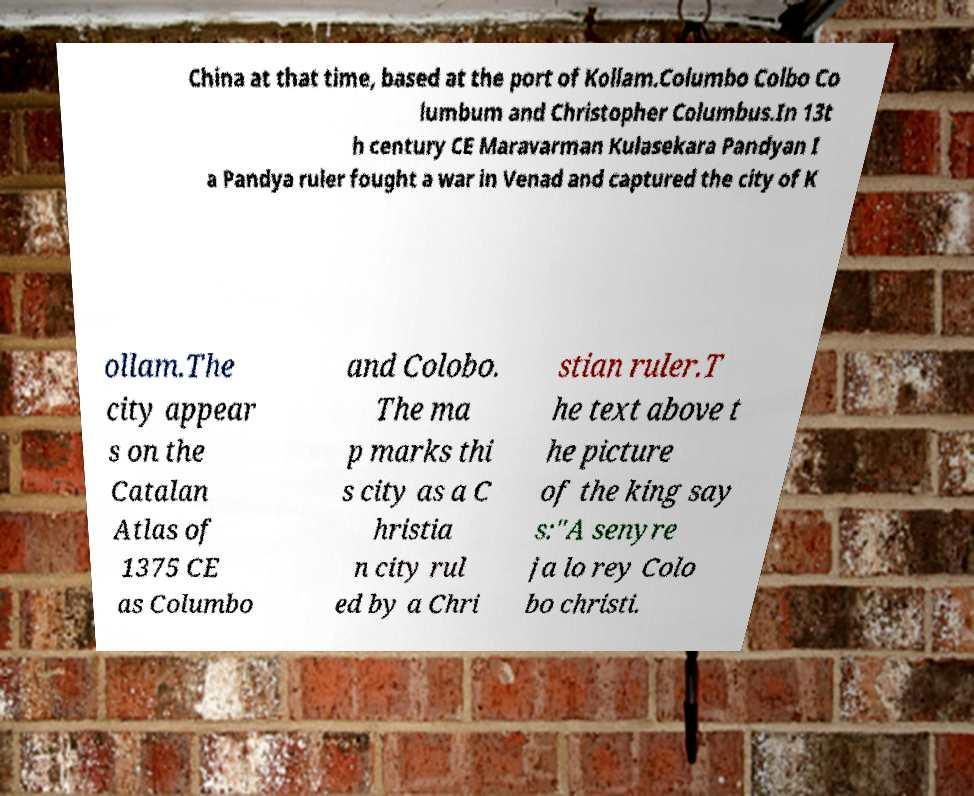Can you read and provide the text displayed in the image?This photo seems to have some interesting text. Can you extract and type it out for me? China at that time, based at the port of Kollam.Columbo Colbo Co lumbum and Christopher Columbus.In 13t h century CE Maravarman Kulasekara Pandyan I a Pandya ruler fought a war in Venad and captured the city of K ollam.The city appear s on the Catalan Atlas of 1375 CE as Columbo and Colobo. The ma p marks thi s city as a C hristia n city rul ed by a Chri stian ruler.T he text above t he picture of the king say s:"A senyre ja lo rey Colo bo christi. 